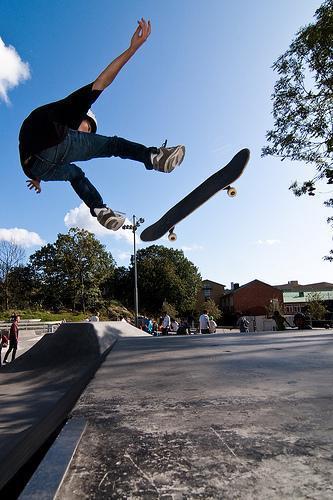How many streetlights?
Give a very brief answer. 1. How many wheels can you see?
Give a very brief answer. 2. How many clouds are there?
Give a very brief answer. 3. How many skateboards are there?
Give a very brief answer. 1. How many skateboarders are in the air?
Give a very brief answer. 1. 